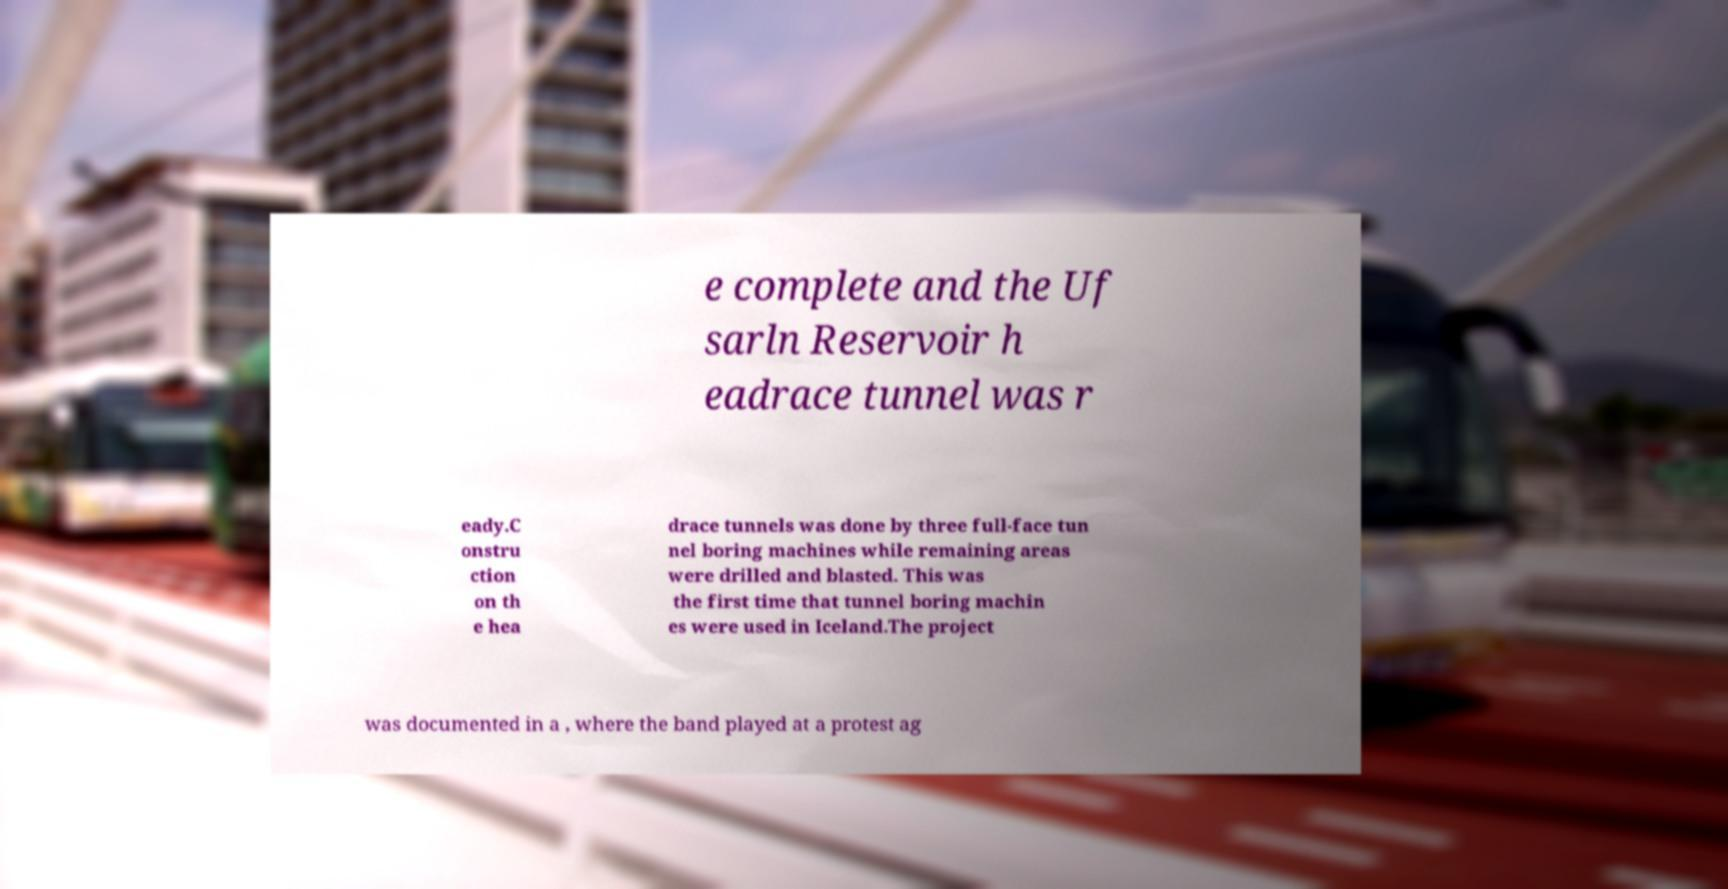Please read and relay the text visible in this image. What does it say? e complete and the Uf sarln Reservoir h eadrace tunnel was r eady.C onstru ction on th e hea drace tunnels was done by three full-face tun nel boring machines while remaining areas were drilled and blasted. This was the first time that tunnel boring machin es were used in Iceland.The project was documented in a , where the band played at a protest ag 